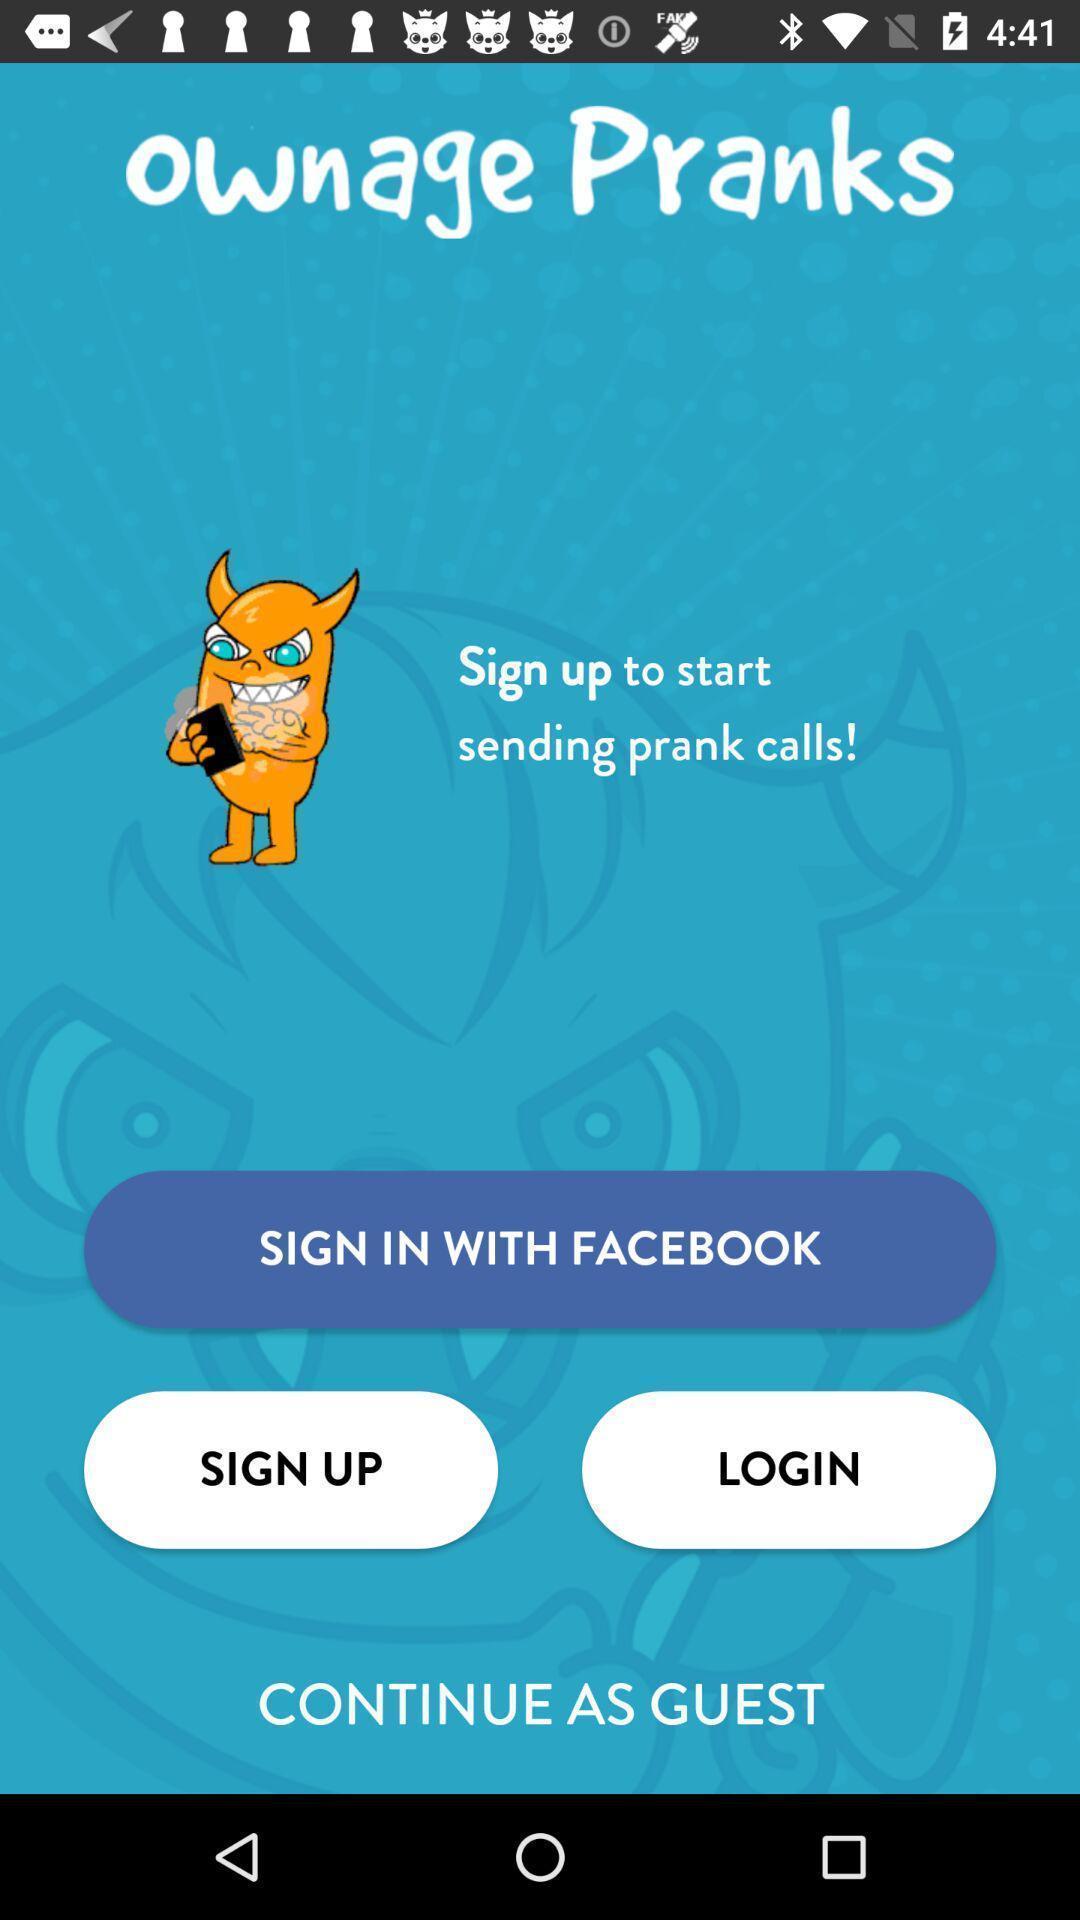Summarize the information in this screenshot. Sign up page for a calling app. 